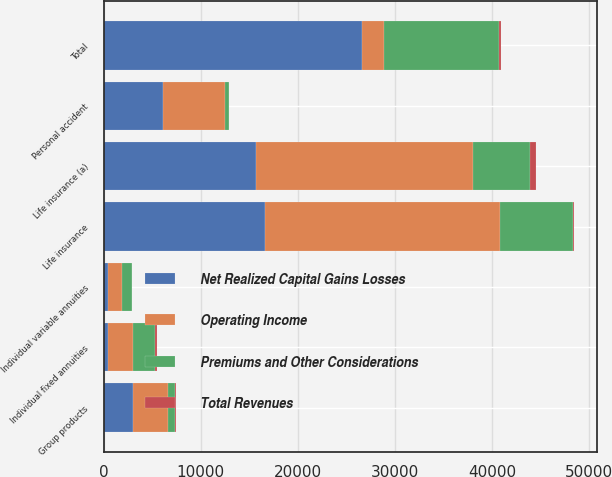Convert chart to OTSL. <chart><loc_0><loc_0><loc_500><loc_500><stacked_bar_chart><ecel><fcel>Life insurance<fcel>Personal accident<fcel>Group products<fcel>Individual fixed annuities<fcel>Individual variable annuities<fcel>Total<fcel>Life insurance (a)<nl><fcel>Net Realized Capital Gains Losses<fcel>16630<fcel>6094<fcel>2979<fcel>438<fcel>460<fcel>26601<fcel>15732<nl><fcel>Premiums and Other Considerations<fcel>7473<fcel>354<fcel>753<fcel>2283<fcel>986<fcel>11849<fcel>5937<nl><fcel>Total Revenues<fcel>85<fcel>3<fcel>76<fcel>171<fcel>22<fcel>187<fcel>574<nl><fcel>Operating Income<fcel>24188<fcel>6445<fcel>3656<fcel>2550<fcel>1424<fcel>2283<fcel>22243<nl></chart> 